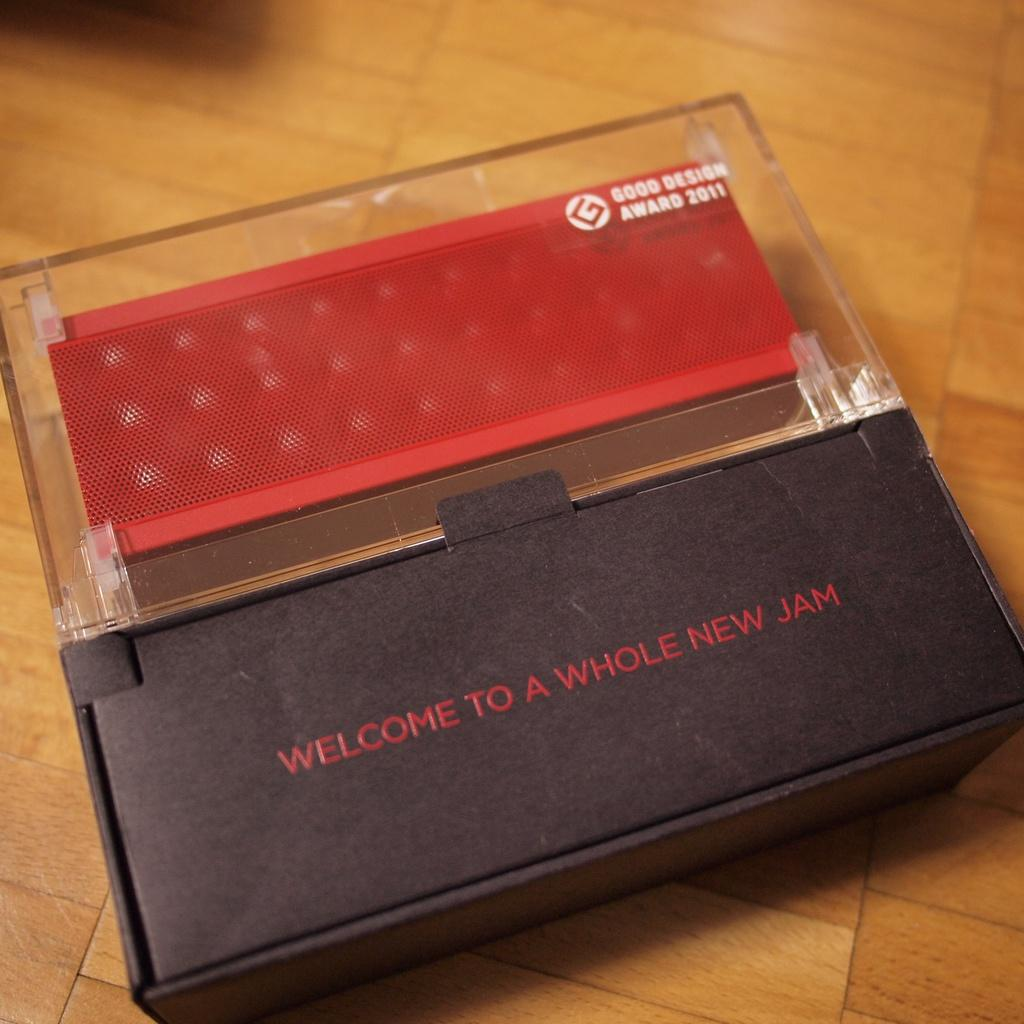<image>
Create a compact narrative representing the image presented. A open case has a plastic top that says Good Design Award 2011. 